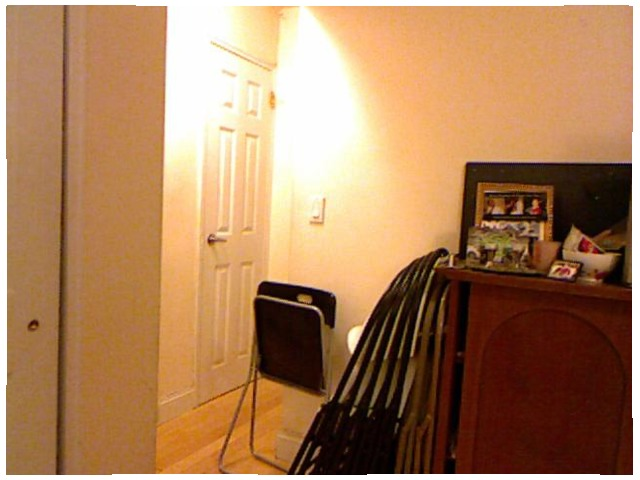<image>
Is the folding chair on the wall? Yes. Looking at the image, I can see the folding chair is positioned on top of the wall, with the wall providing support. Where is the light in relation to the wall? Is it on the wall? Yes. Looking at the image, I can see the light is positioned on top of the wall, with the wall providing support. Where is the chair in relation to the cupboard? Is it to the right of the cupboard? No. The chair is not to the right of the cupboard. The horizontal positioning shows a different relationship. 